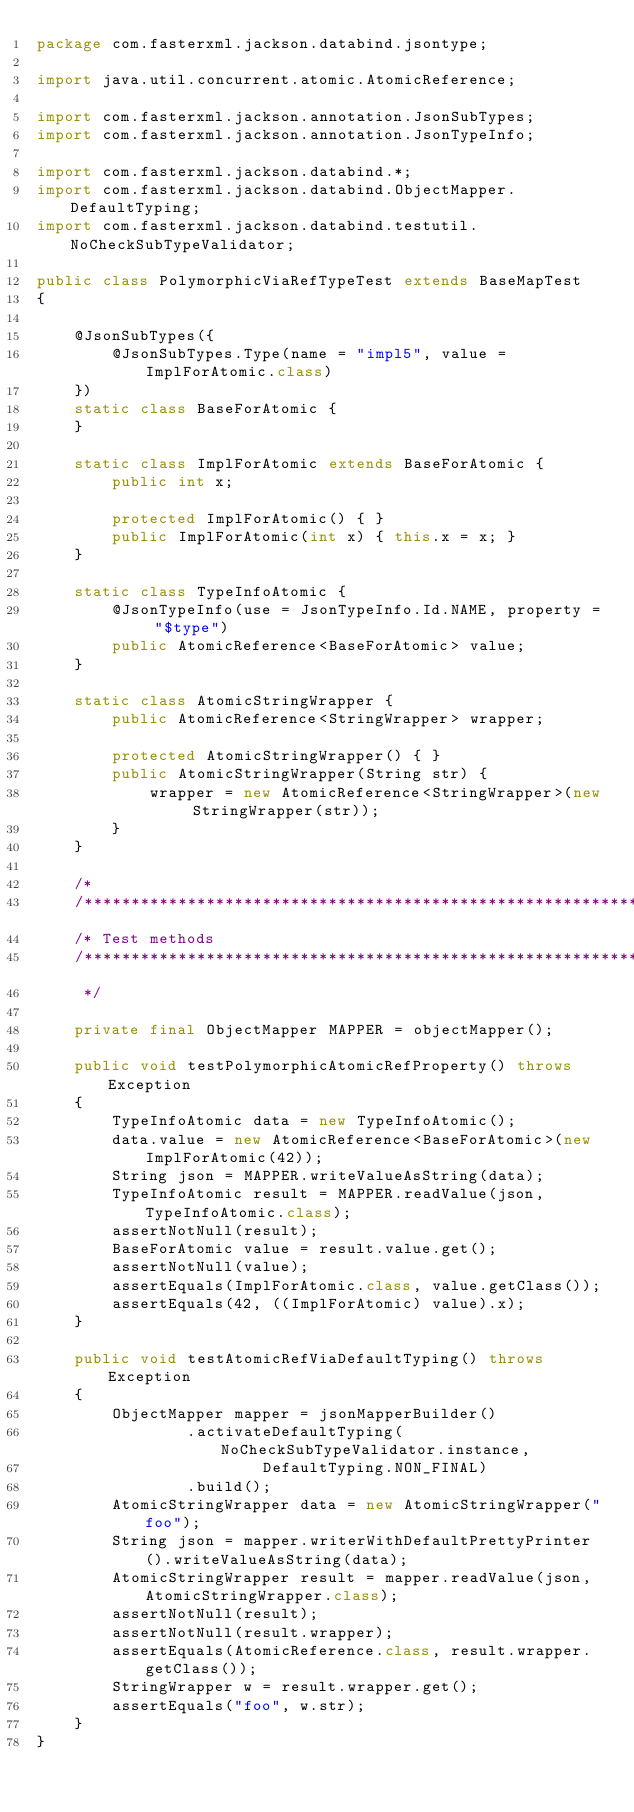<code> <loc_0><loc_0><loc_500><loc_500><_Java_>package com.fasterxml.jackson.databind.jsontype;

import java.util.concurrent.atomic.AtomicReference;

import com.fasterxml.jackson.annotation.JsonSubTypes;
import com.fasterxml.jackson.annotation.JsonTypeInfo;

import com.fasterxml.jackson.databind.*;
import com.fasterxml.jackson.databind.ObjectMapper.DefaultTyping;
import com.fasterxml.jackson.databind.testutil.NoCheckSubTypeValidator;

public class PolymorphicViaRefTypeTest extends BaseMapTest
{
    
    @JsonSubTypes({
        @JsonSubTypes.Type(name = "impl5", value = ImplForAtomic.class)
    })
    static class BaseForAtomic {
    }

    static class ImplForAtomic extends BaseForAtomic {
        public int x;

        protected ImplForAtomic() { }
        public ImplForAtomic(int x) { this.x = x; }
    }

    static class TypeInfoAtomic {
        @JsonTypeInfo(use = JsonTypeInfo.Id.NAME, property = "$type")
        public AtomicReference<BaseForAtomic> value;
    }

    static class AtomicStringWrapper {
        public AtomicReference<StringWrapper> wrapper;

        protected AtomicStringWrapper() { }
        public AtomicStringWrapper(String str) {
            wrapper = new AtomicReference<StringWrapper>(new StringWrapper(str));
        }
    }

    /*
    /**********************************************************************
    /* Test methods
    /**********************************************************************
     */

    private final ObjectMapper MAPPER = objectMapper();

    public void testPolymorphicAtomicRefProperty() throws Exception
    {
        TypeInfoAtomic data = new TypeInfoAtomic();
        data.value = new AtomicReference<BaseForAtomic>(new ImplForAtomic(42));
        String json = MAPPER.writeValueAsString(data);
        TypeInfoAtomic result = MAPPER.readValue(json, TypeInfoAtomic.class);
        assertNotNull(result);
        BaseForAtomic value = result.value.get();
        assertNotNull(value);
        assertEquals(ImplForAtomic.class, value.getClass());
        assertEquals(42, ((ImplForAtomic) value).x);
    }

    public void testAtomicRefViaDefaultTyping() throws Exception
    {
        ObjectMapper mapper = jsonMapperBuilder()
                .activateDefaultTyping(NoCheckSubTypeValidator.instance,
                        DefaultTyping.NON_FINAL)
                .build();
        AtomicStringWrapper data = new AtomicStringWrapper("foo");
        String json = mapper.writerWithDefaultPrettyPrinter().writeValueAsString(data);
        AtomicStringWrapper result = mapper.readValue(json, AtomicStringWrapper.class);
        assertNotNull(result);
        assertNotNull(result.wrapper);
        assertEquals(AtomicReference.class, result.wrapper.getClass());
        StringWrapper w = result.wrapper.get();
        assertEquals("foo", w.str);
    }
}
</code> 